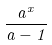Convert formula to latex. <formula><loc_0><loc_0><loc_500><loc_500>\frac { a ^ { x } } { a - 1 }</formula> 